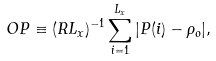Convert formula to latex. <formula><loc_0><loc_0><loc_500><loc_500>O P \equiv ( R L _ { x } ) ^ { - 1 } \sum _ { i = 1 } ^ { L _ { x } } | P ( i ) - \rho _ { o } | ,</formula> 